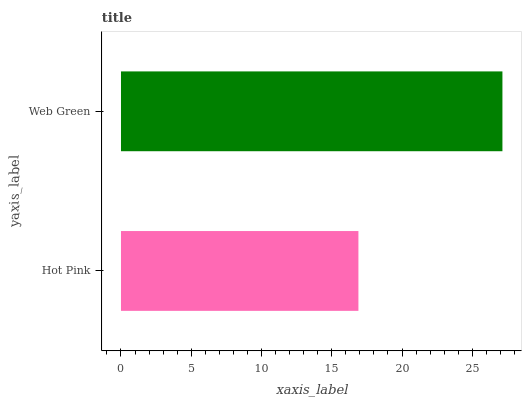Is Hot Pink the minimum?
Answer yes or no. Yes. Is Web Green the maximum?
Answer yes or no. Yes. Is Web Green the minimum?
Answer yes or no. No. Is Web Green greater than Hot Pink?
Answer yes or no. Yes. Is Hot Pink less than Web Green?
Answer yes or no. Yes. Is Hot Pink greater than Web Green?
Answer yes or no. No. Is Web Green less than Hot Pink?
Answer yes or no. No. Is Web Green the high median?
Answer yes or no. Yes. Is Hot Pink the low median?
Answer yes or no. Yes. Is Hot Pink the high median?
Answer yes or no. No. Is Web Green the low median?
Answer yes or no. No. 